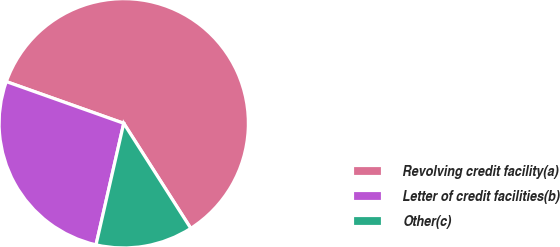<chart> <loc_0><loc_0><loc_500><loc_500><pie_chart><fcel>Revolving credit facility(a)<fcel>Letter of credit facilities(b)<fcel>Other(c)<nl><fcel>60.53%<fcel>26.86%<fcel>12.61%<nl></chart> 